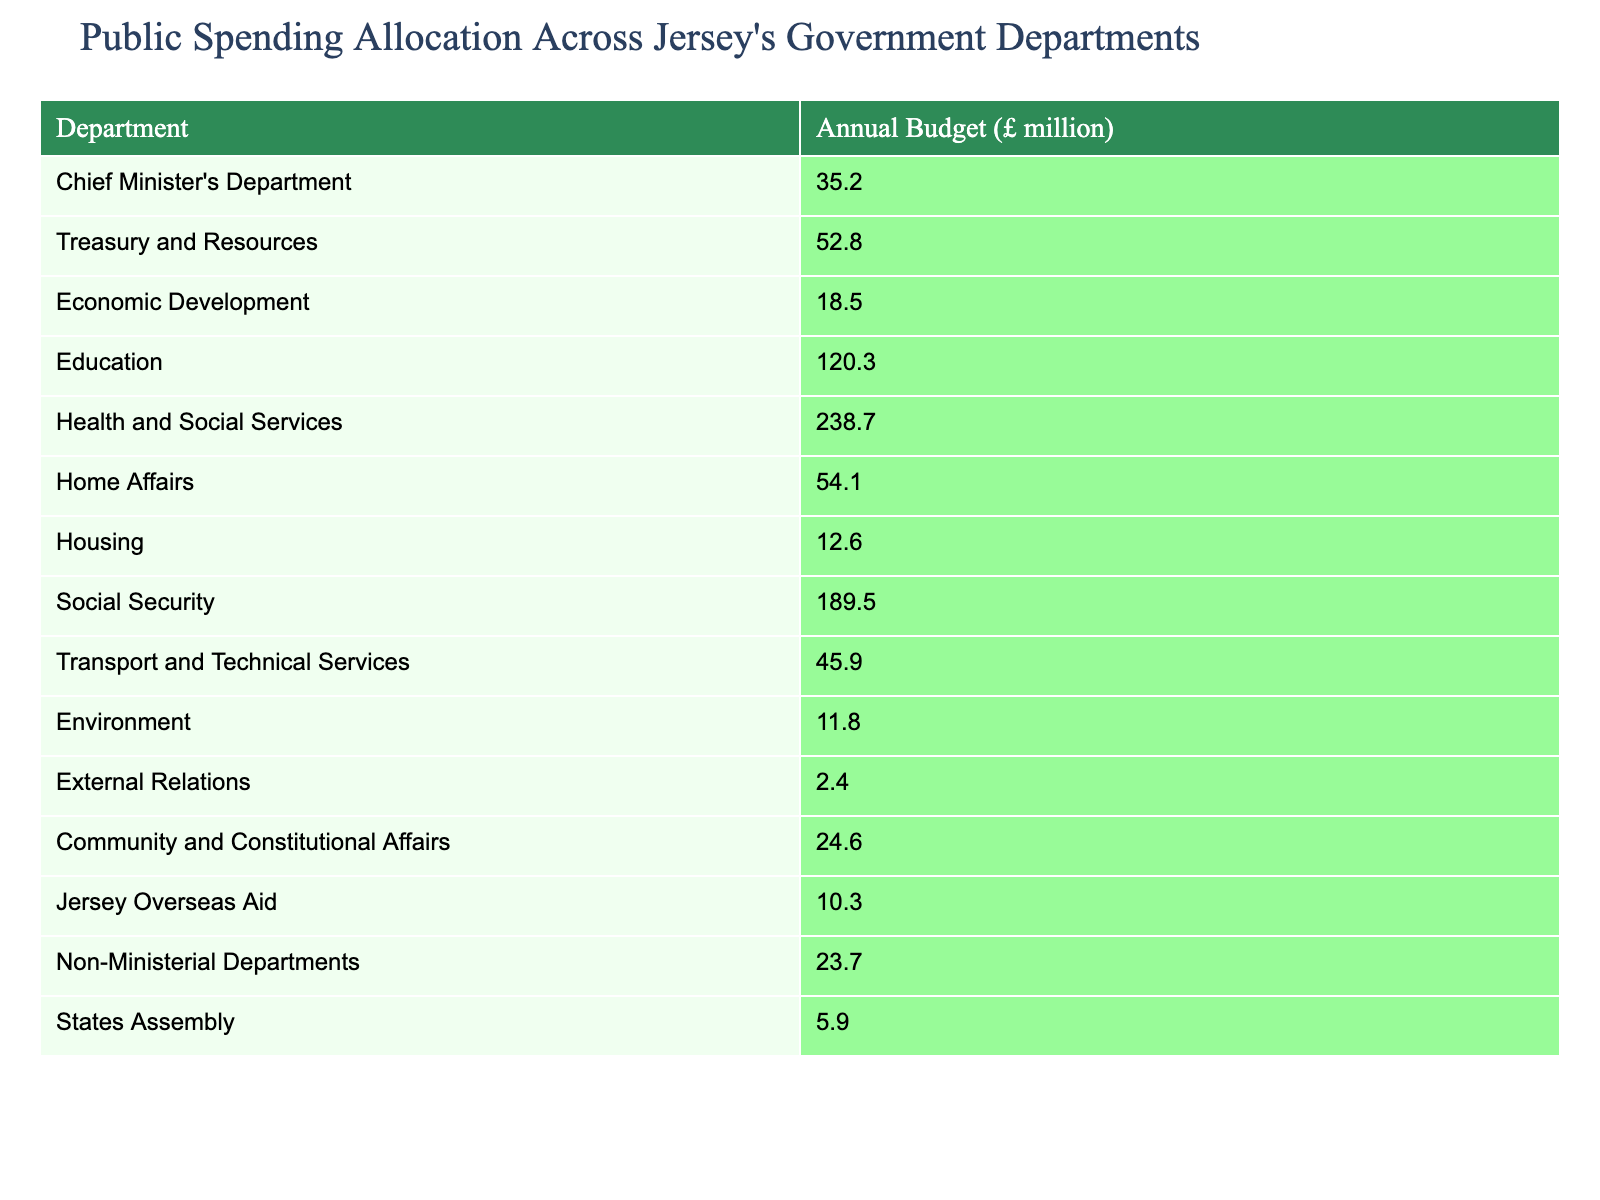What's the annual budget for the Education department? The annual budget for the Education department is directly found in the table. It states £120.3 million as the budget amount for this department.
Answer: £120.3 million Which department has the largest budget? By scanning the budget amounts listed, the Health and Social Services department has the largest budget of £238.7 million.
Answer: Health and Social Services What is the total annual budget for all departments? To find the total annual budget, all individual departmental budgets must be summed: 35.2 + 52.8 + 18.5 + 120.3 + 238.7 + 54.1 + 12.6 + 189.5 + 45.9 + 11.8 + 2.4 + 24.6 + 10.3 + 23.7 + 5.9 =  805.5 million.
Answer: £805.5 million Is the budget for Social Security greater than the sum of the budgets for Housing and Environment? The budget for Social Security is £189.5 million. The sum of Housing (£12.6 million) and Environment (£11.8 million) is £24.4 million. Since £189.5 million is greater than £24.4 million, the statement is true.
Answer: Yes What is the difference in budget between the Chief Minister's Department and Home Affairs? The budget for Chief Minister's Department is £35.2 million, and for Home Affairs, it is £54.1 million. To find the difference: £54.1 million - £35.2 million = £18.9 million.
Answer: £18.9 million Which department's budget is closest to the average budget of all the departments? First, calculate the average budget: Total budget (£805.5 million) divided by the number of departments (15), which gives £53.7 million. From the table, Transport and Technical Services has a budget of £45.9 million, which is the closest to the average.
Answer: Transport and Technical Services What percentage of the total budget is allocated to Health and Social Services? First, take the budget for Health and Social Services (£238.7 million) and divide it by the total budget (£805.5 million). Then multiply by 100 to get the percentage: (£238.7 / 805.5) * 100 = approximately 29.6%.
Answer: 29.6% Do more than half of the departments have a budget over £50 million? There are 15 departments total. The departments with budgets over £50 million are Treasury and Resources, Health and Social Services, Home Affairs, and Education. That makes 4 out of 15, which is not more than half (7.5).
Answer: No What is the combined budget of the smallest three departments? The three smallest budgets are External Relations (£2.4 million), Housing (£12.6 million), and Environment (£11.8 million). Their combined budget is £2.4 + £12.6 + £11.8 = £26.8 million.
Answer: £26.8 million Which department receives the least funding? By looking at the budgets listed, External Relations has the smallest budget of £2.4 million.
Answer: External Relations What is the ratio of the budget of Economic Development to the budget of Housing? Economic Development has a budget of £18.5 million, and Housing has a budget of £12.6 million. The ratio is 18.5:12.6, which simplifies to approximately 1.47:1.
Answer: 1.47:1 